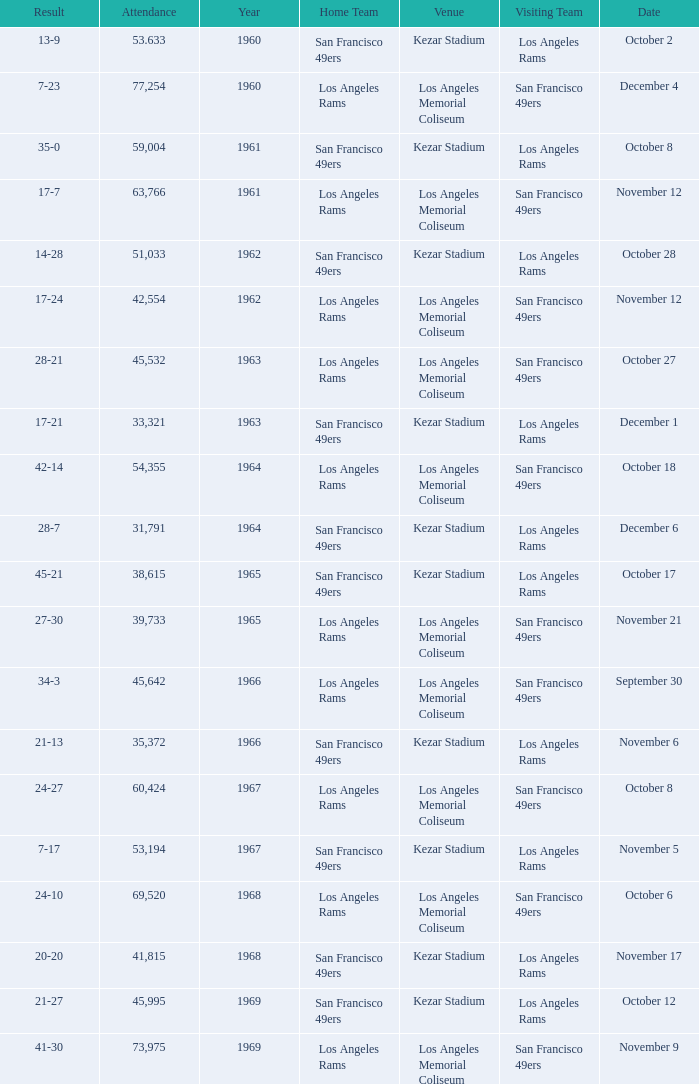When was the earliest year when the attendance was 77,254? 1960.0. 